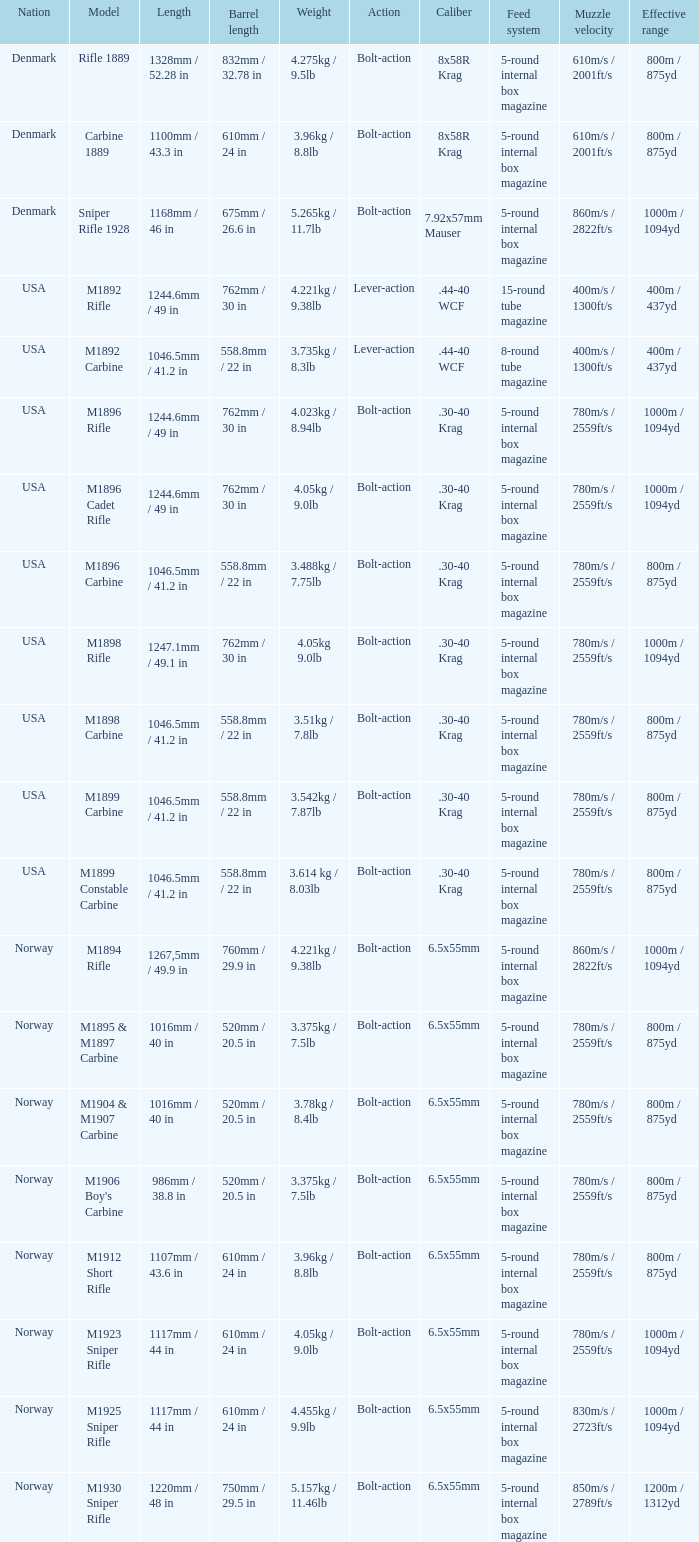5 inches? 1220mm / 48 in. 